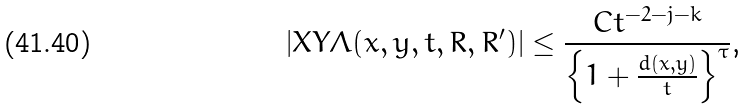<formula> <loc_0><loc_0><loc_500><loc_500>\left | X Y \Lambda ( x , y , t , R , R ^ { \prime } ) \right | \leq \frac { C t ^ { - 2 - j - k } } { \left \{ 1 + \frac { d ( x , y ) } { t } \right \} ^ { \tau } } \text {,}</formula> 